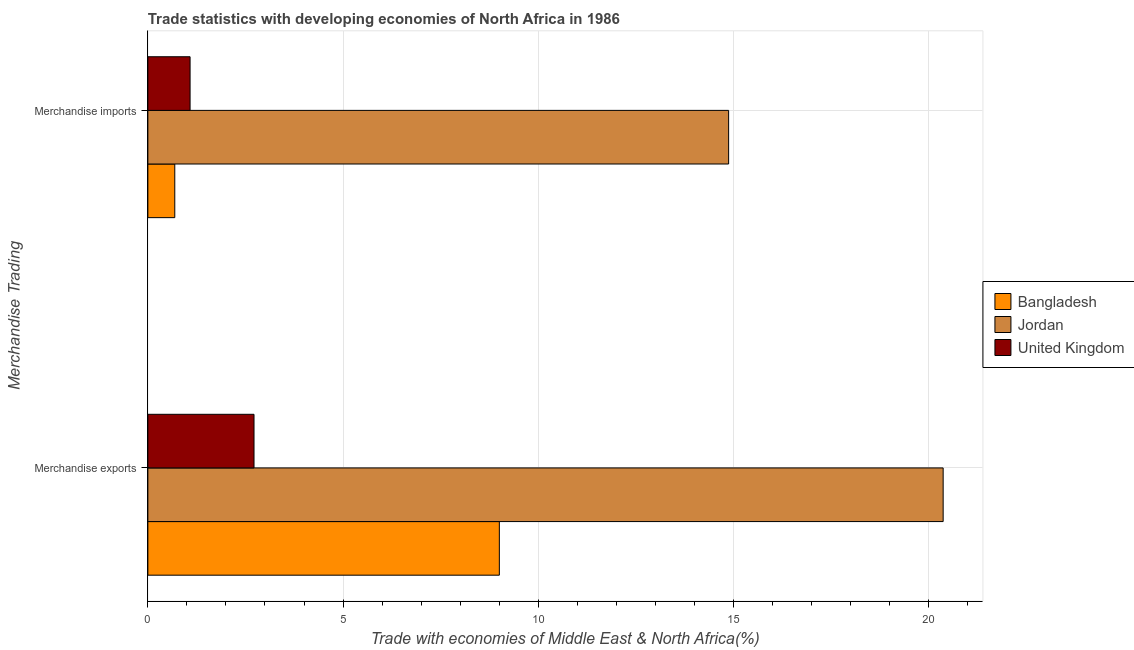How many groups of bars are there?
Your response must be concise. 2. Are the number of bars per tick equal to the number of legend labels?
Make the answer very short. Yes. Are the number of bars on each tick of the Y-axis equal?
Make the answer very short. Yes. What is the merchandise exports in Bangladesh?
Your answer should be compact. 9. Across all countries, what is the maximum merchandise exports?
Provide a succinct answer. 20.37. Across all countries, what is the minimum merchandise imports?
Keep it short and to the point. 0.69. In which country was the merchandise exports maximum?
Your answer should be compact. Jordan. In which country was the merchandise imports minimum?
Offer a terse response. Bangladesh. What is the total merchandise exports in the graph?
Give a very brief answer. 32.09. What is the difference between the merchandise exports in Jordan and that in United Kingdom?
Your response must be concise. 17.65. What is the difference between the merchandise imports in United Kingdom and the merchandise exports in Jordan?
Keep it short and to the point. -19.29. What is the average merchandise imports per country?
Provide a short and direct response. 5.55. What is the difference between the merchandise imports and merchandise exports in Jordan?
Keep it short and to the point. -5.5. What is the ratio of the merchandise imports in Jordan to that in Bangladesh?
Keep it short and to the point. 21.58. Is the merchandise imports in Jordan less than that in United Kingdom?
Offer a very short reply. No. In how many countries, is the merchandise imports greater than the average merchandise imports taken over all countries?
Offer a very short reply. 1. What does the 2nd bar from the bottom in Merchandise exports represents?
Keep it short and to the point. Jordan. Are all the bars in the graph horizontal?
Provide a short and direct response. Yes. What is the difference between two consecutive major ticks on the X-axis?
Your answer should be compact. 5. Are the values on the major ticks of X-axis written in scientific E-notation?
Your answer should be very brief. No. Where does the legend appear in the graph?
Offer a terse response. Center right. What is the title of the graph?
Offer a very short reply. Trade statistics with developing economies of North Africa in 1986. What is the label or title of the X-axis?
Provide a succinct answer. Trade with economies of Middle East & North Africa(%). What is the label or title of the Y-axis?
Provide a short and direct response. Merchandise Trading. What is the Trade with economies of Middle East & North Africa(%) in Bangladesh in Merchandise exports?
Make the answer very short. 9. What is the Trade with economies of Middle East & North Africa(%) of Jordan in Merchandise exports?
Your response must be concise. 20.37. What is the Trade with economies of Middle East & North Africa(%) in United Kingdom in Merchandise exports?
Your answer should be very brief. 2.72. What is the Trade with economies of Middle East & North Africa(%) of Bangladesh in Merchandise imports?
Your answer should be compact. 0.69. What is the Trade with economies of Middle East & North Africa(%) in Jordan in Merchandise imports?
Ensure brevity in your answer.  14.88. What is the Trade with economies of Middle East & North Africa(%) of United Kingdom in Merchandise imports?
Your answer should be very brief. 1.08. Across all Merchandise Trading, what is the maximum Trade with economies of Middle East & North Africa(%) of Bangladesh?
Ensure brevity in your answer.  9. Across all Merchandise Trading, what is the maximum Trade with economies of Middle East & North Africa(%) in Jordan?
Give a very brief answer. 20.37. Across all Merchandise Trading, what is the maximum Trade with economies of Middle East & North Africa(%) of United Kingdom?
Give a very brief answer. 2.72. Across all Merchandise Trading, what is the minimum Trade with economies of Middle East & North Africa(%) of Bangladesh?
Provide a succinct answer. 0.69. Across all Merchandise Trading, what is the minimum Trade with economies of Middle East & North Africa(%) in Jordan?
Your response must be concise. 14.88. Across all Merchandise Trading, what is the minimum Trade with economies of Middle East & North Africa(%) in United Kingdom?
Offer a very short reply. 1.08. What is the total Trade with economies of Middle East & North Africa(%) of Bangladesh in the graph?
Give a very brief answer. 9.69. What is the total Trade with economies of Middle East & North Africa(%) in Jordan in the graph?
Offer a terse response. 35.25. What is the total Trade with economies of Middle East & North Africa(%) in United Kingdom in the graph?
Ensure brevity in your answer.  3.8. What is the difference between the Trade with economies of Middle East & North Africa(%) in Bangladesh in Merchandise exports and that in Merchandise imports?
Provide a short and direct response. 8.31. What is the difference between the Trade with economies of Middle East & North Africa(%) of Jordan in Merchandise exports and that in Merchandise imports?
Give a very brief answer. 5.5. What is the difference between the Trade with economies of Middle East & North Africa(%) in United Kingdom in Merchandise exports and that in Merchandise imports?
Your response must be concise. 1.64. What is the difference between the Trade with economies of Middle East & North Africa(%) in Bangladesh in Merchandise exports and the Trade with economies of Middle East & North Africa(%) in Jordan in Merchandise imports?
Your answer should be compact. -5.87. What is the difference between the Trade with economies of Middle East & North Africa(%) of Bangladesh in Merchandise exports and the Trade with economies of Middle East & North Africa(%) of United Kingdom in Merchandise imports?
Keep it short and to the point. 7.92. What is the difference between the Trade with economies of Middle East & North Africa(%) in Jordan in Merchandise exports and the Trade with economies of Middle East & North Africa(%) in United Kingdom in Merchandise imports?
Your answer should be compact. 19.29. What is the average Trade with economies of Middle East & North Africa(%) of Bangladesh per Merchandise Trading?
Provide a succinct answer. 4.85. What is the average Trade with economies of Middle East & North Africa(%) in Jordan per Merchandise Trading?
Your response must be concise. 17.62. What is the average Trade with economies of Middle East & North Africa(%) of United Kingdom per Merchandise Trading?
Your answer should be very brief. 1.9. What is the difference between the Trade with economies of Middle East & North Africa(%) in Bangladesh and Trade with economies of Middle East & North Africa(%) in Jordan in Merchandise exports?
Give a very brief answer. -11.37. What is the difference between the Trade with economies of Middle East & North Africa(%) in Bangladesh and Trade with economies of Middle East & North Africa(%) in United Kingdom in Merchandise exports?
Give a very brief answer. 6.28. What is the difference between the Trade with economies of Middle East & North Africa(%) in Jordan and Trade with economies of Middle East & North Africa(%) in United Kingdom in Merchandise exports?
Offer a terse response. 17.65. What is the difference between the Trade with economies of Middle East & North Africa(%) in Bangladesh and Trade with economies of Middle East & North Africa(%) in Jordan in Merchandise imports?
Offer a very short reply. -14.19. What is the difference between the Trade with economies of Middle East & North Africa(%) of Bangladesh and Trade with economies of Middle East & North Africa(%) of United Kingdom in Merchandise imports?
Offer a terse response. -0.39. What is the difference between the Trade with economies of Middle East & North Africa(%) in Jordan and Trade with economies of Middle East & North Africa(%) in United Kingdom in Merchandise imports?
Provide a short and direct response. 13.79. What is the ratio of the Trade with economies of Middle East & North Africa(%) in Bangladesh in Merchandise exports to that in Merchandise imports?
Ensure brevity in your answer.  13.06. What is the ratio of the Trade with economies of Middle East & North Africa(%) in Jordan in Merchandise exports to that in Merchandise imports?
Offer a very short reply. 1.37. What is the ratio of the Trade with economies of Middle East & North Africa(%) of United Kingdom in Merchandise exports to that in Merchandise imports?
Your answer should be very brief. 2.51. What is the difference between the highest and the second highest Trade with economies of Middle East & North Africa(%) in Bangladesh?
Offer a very short reply. 8.31. What is the difference between the highest and the second highest Trade with economies of Middle East & North Africa(%) of Jordan?
Keep it short and to the point. 5.5. What is the difference between the highest and the second highest Trade with economies of Middle East & North Africa(%) in United Kingdom?
Your answer should be compact. 1.64. What is the difference between the highest and the lowest Trade with economies of Middle East & North Africa(%) in Bangladesh?
Keep it short and to the point. 8.31. What is the difference between the highest and the lowest Trade with economies of Middle East & North Africa(%) in Jordan?
Offer a terse response. 5.5. What is the difference between the highest and the lowest Trade with economies of Middle East & North Africa(%) of United Kingdom?
Offer a terse response. 1.64. 